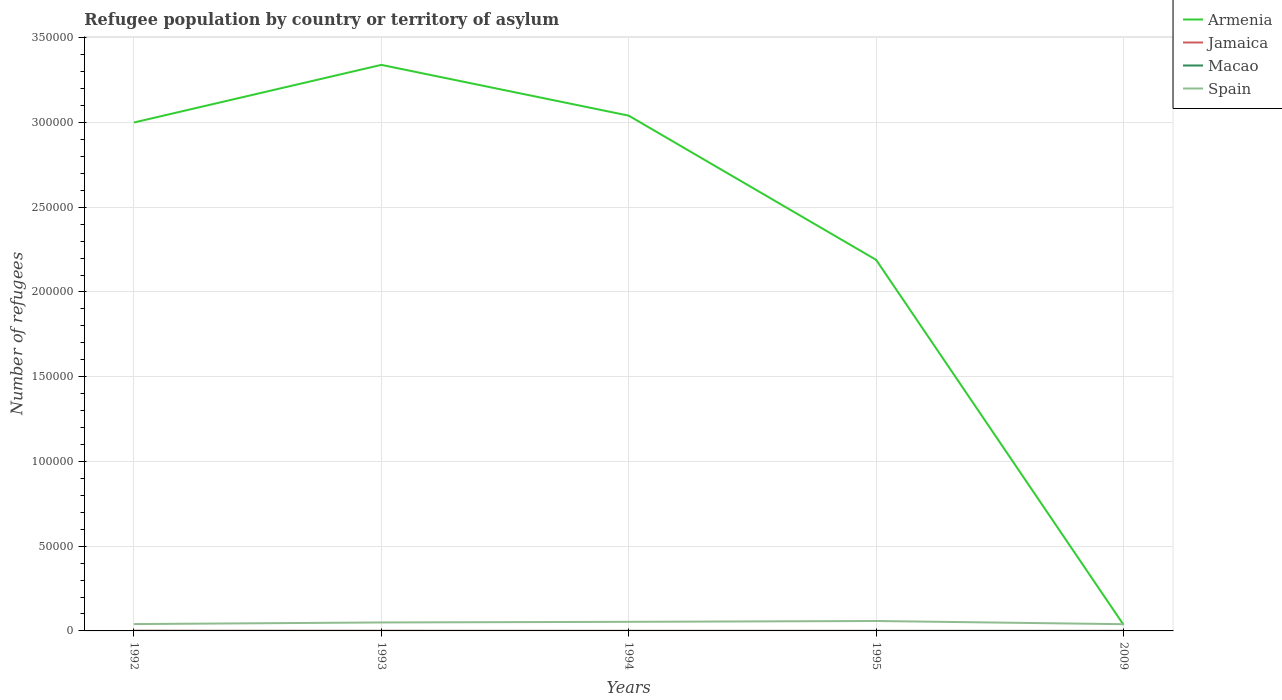Does the line corresponding to Armenia intersect with the line corresponding to Macao?
Keep it short and to the point. No. Is the number of lines equal to the number of legend labels?
Provide a succinct answer. Yes. Across all years, what is the maximum number of refugees in Spain?
Offer a very short reply. 3970. What is the total number of refugees in Armenia in the graph?
Provide a succinct answer. 1.15e+05. How many lines are there?
Ensure brevity in your answer.  4. How many years are there in the graph?
Ensure brevity in your answer.  5. Are the values on the major ticks of Y-axis written in scientific E-notation?
Ensure brevity in your answer.  No. Does the graph contain grids?
Your answer should be compact. Yes. Where does the legend appear in the graph?
Provide a succinct answer. Top right. How many legend labels are there?
Make the answer very short. 4. What is the title of the graph?
Provide a short and direct response. Refugee population by country or territory of asylum. Does "Lithuania" appear as one of the legend labels in the graph?
Give a very brief answer. No. What is the label or title of the X-axis?
Ensure brevity in your answer.  Years. What is the label or title of the Y-axis?
Make the answer very short. Number of refugees. What is the Number of refugees in Macao in 1992?
Keep it short and to the point. 15. What is the Number of refugees in Spain in 1992?
Offer a very short reply. 4036. What is the Number of refugees of Armenia in 1993?
Offer a very short reply. 3.34e+05. What is the Number of refugees in Spain in 1993?
Provide a succinct answer. 4997. What is the Number of refugees of Armenia in 1994?
Keep it short and to the point. 3.04e+05. What is the Number of refugees of Jamaica in 1994?
Offer a very short reply. 41. What is the Number of refugees in Macao in 1994?
Keep it short and to the point. 9. What is the Number of refugees in Spain in 1994?
Your answer should be compact. 5361. What is the Number of refugees in Armenia in 1995?
Keep it short and to the point. 2.19e+05. What is the Number of refugees of Spain in 1995?
Provide a succinct answer. 5852. What is the Number of refugees in Armenia in 2009?
Your answer should be very brief. 3607. What is the Number of refugees of Jamaica in 2009?
Give a very brief answer. 26. What is the Number of refugees of Macao in 2009?
Your answer should be very brief. 6. What is the Number of refugees of Spain in 2009?
Provide a succinct answer. 3970. Across all years, what is the maximum Number of refugees in Armenia?
Offer a terse response. 3.34e+05. Across all years, what is the maximum Number of refugees of Macao?
Your response must be concise. 15. Across all years, what is the maximum Number of refugees of Spain?
Offer a very short reply. 5852. Across all years, what is the minimum Number of refugees in Armenia?
Ensure brevity in your answer.  3607. Across all years, what is the minimum Number of refugees in Jamaica?
Your answer should be compact. 23. Across all years, what is the minimum Number of refugees in Spain?
Keep it short and to the point. 3970. What is the total Number of refugees in Armenia in the graph?
Offer a terse response. 1.16e+06. What is the total Number of refugees in Jamaica in the graph?
Your answer should be very brief. 243. What is the total Number of refugees of Spain in the graph?
Offer a terse response. 2.42e+04. What is the difference between the Number of refugees in Armenia in 1992 and that in 1993?
Offer a very short reply. -3.40e+04. What is the difference between the Number of refugees in Macao in 1992 and that in 1993?
Your answer should be very brief. 5. What is the difference between the Number of refugees in Spain in 1992 and that in 1993?
Provide a succinct answer. -961. What is the difference between the Number of refugees in Armenia in 1992 and that in 1994?
Offer a very short reply. -4039. What is the difference between the Number of refugees of Jamaica in 1992 and that in 1994?
Ensure brevity in your answer.  49. What is the difference between the Number of refugees in Macao in 1992 and that in 1994?
Provide a short and direct response. 6. What is the difference between the Number of refugees of Spain in 1992 and that in 1994?
Keep it short and to the point. -1325. What is the difference between the Number of refugees of Armenia in 1992 and that in 1995?
Offer a terse response. 8.10e+04. What is the difference between the Number of refugees of Jamaica in 1992 and that in 1995?
Provide a succinct answer. 67. What is the difference between the Number of refugees in Macao in 1992 and that in 1995?
Your response must be concise. 7. What is the difference between the Number of refugees in Spain in 1992 and that in 1995?
Provide a short and direct response. -1816. What is the difference between the Number of refugees of Armenia in 1992 and that in 2009?
Keep it short and to the point. 2.96e+05. What is the difference between the Number of refugees in Jamaica in 1992 and that in 2009?
Provide a succinct answer. 64. What is the difference between the Number of refugees of Spain in 1992 and that in 2009?
Your answer should be compact. 66. What is the difference between the Number of refugees of Armenia in 1993 and that in 1994?
Ensure brevity in your answer.  3.00e+04. What is the difference between the Number of refugees in Macao in 1993 and that in 1994?
Your response must be concise. 1. What is the difference between the Number of refugees of Spain in 1993 and that in 1994?
Your answer should be compact. -364. What is the difference between the Number of refugees of Armenia in 1993 and that in 1995?
Provide a short and direct response. 1.15e+05. What is the difference between the Number of refugees in Macao in 1993 and that in 1995?
Give a very brief answer. 2. What is the difference between the Number of refugees in Spain in 1993 and that in 1995?
Ensure brevity in your answer.  -855. What is the difference between the Number of refugees of Armenia in 1993 and that in 2009?
Make the answer very short. 3.30e+05. What is the difference between the Number of refugees in Macao in 1993 and that in 2009?
Make the answer very short. 4. What is the difference between the Number of refugees in Spain in 1993 and that in 2009?
Offer a very short reply. 1027. What is the difference between the Number of refugees in Armenia in 1994 and that in 1995?
Your answer should be compact. 8.51e+04. What is the difference between the Number of refugees of Jamaica in 1994 and that in 1995?
Your answer should be very brief. 18. What is the difference between the Number of refugees of Spain in 1994 and that in 1995?
Offer a very short reply. -491. What is the difference between the Number of refugees in Armenia in 1994 and that in 2009?
Offer a very short reply. 3.00e+05. What is the difference between the Number of refugees in Jamaica in 1994 and that in 2009?
Offer a terse response. 15. What is the difference between the Number of refugees in Macao in 1994 and that in 2009?
Make the answer very short. 3. What is the difference between the Number of refugees of Spain in 1994 and that in 2009?
Your response must be concise. 1391. What is the difference between the Number of refugees of Armenia in 1995 and that in 2009?
Your answer should be very brief. 2.15e+05. What is the difference between the Number of refugees of Jamaica in 1995 and that in 2009?
Your answer should be compact. -3. What is the difference between the Number of refugees in Macao in 1995 and that in 2009?
Your answer should be compact. 2. What is the difference between the Number of refugees of Spain in 1995 and that in 2009?
Offer a very short reply. 1882. What is the difference between the Number of refugees in Armenia in 1992 and the Number of refugees in Jamaica in 1993?
Offer a very short reply. 3.00e+05. What is the difference between the Number of refugees of Armenia in 1992 and the Number of refugees of Macao in 1993?
Your answer should be very brief. 3.00e+05. What is the difference between the Number of refugees in Armenia in 1992 and the Number of refugees in Spain in 1993?
Provide a succinct answer. 2.95e+05. What is the difference between the Number of refugees in Jamaica in 1992 and the Number of refugees in Spain in 1993?
Your answer should be compact. -4907. What is the difference between the Number of refugees in Macao in 1992 and the Number of refugees in Spain in 1993?
Provide a succinct answer. -4982. What is the difference between the Number of refugees of Armenia in 1992 and the Number of refugees of Jamaica in 1994?
Keep it short and to the point. 3.00e+05. What is the difference between the Number of refugees of Armenia in 1992 and the Number of refugees of Macao in 1994?
Provide a succinct answer. 3.00e+05. What is the difference between the Number of refugees in Armenia in 1992 and the Number of refugees in Spain in 1994?
Provide a succinct answer. 2.95e+05. What is the difference between the Number of refugees in Jamaica in 1992 and the Number of refugees in Macao in 1994?
Provide a short and direct response. 81. What is the difference between the Number of refugees in Jamaica in 1992 and the Number of refugees in Spain in 1994?
Offer a very short reply. -5271. What is the difference between the Number of refugees of Macao in 1992 and the Number of refugees of Spain in 1994?
Provide a short and direct response. -5346. What is the difference between the Number of refugees of Armenia in 1992 and the Number of refugees of Jamaica in 1995?
Provide a succinct answer. 3.00e+05. What is the difference between the Number of refugees of Armenia in 1992 and the Number of refugees of Macao in 1995?
Your response must be concise. 3.00e+05. What is the difference between the Number of refugees of Armenia in 1992 and the Number of refugees of Spain in 1995?
Give a very brief answer. 2.94e+05. What is the difference between the Number of refugees in Jamaica in 1992 and the Number of refugees in Spain in 1995?
Provide a succinct answer. -5762. What is the difference between the Number of refugees of Macao in 1992 and the Number of refugees of Spain in 1995?
Ensure brevity in your answer.  -5837. What is the difference between the Number of refugees of Armenia in 1992 and the Number of refugees of Jamaica in 2009?
Offer a very short reply. 3.00e+05. What is the difference between the Number of refugees of Armenia in 1992 and the Number of refugees of Macao in 2009?
Ensure brevity in your answer.  3.00e+05. What is the difference between the Number of refugees of Armenia in 1992 and the Number of refugees of Spain in 2009?
Give a very brief answer. 2.96e+05. What is the difference between the Number of refugees of Jamaica in 1992 and the Number of refugees of Spain in 2009?
Offer a very short reply. -3880. What is the difference between the Number of refugees of Macao in 1992 and the Number of refugees of Spain in 2009?
Offer a terse response. -3955. What is the difference between the Number of refugees in Armenia in 1993 and the Number of refugees in Jamaica in 1994?
Provide a succinct answer. 3.34e+05. What is the difference between the Number of refugees in Armenia in 1993 and the Number of refugees in Macao in 1994?
Ensure brevity in your answer.  3.34e+05. What is the difference between the Number of refugees of Armenia in 1993 and the Number of refugees of Spain in 1994?
Keep it short and to the point. 3.29e+05. What is the difference between the Number of refugees of Jamaica in 1993 and the Number of refugees of Spain in 1994?
Your answer should be compact. -5298. What is the difference between the Number of refugees of Macao in 1993 and the Number of refugees of Spain in 1994?
Give a very brief answer. -5351. What is the difference between the Number of refugees of Armenia in 1993 and the Number of refugees of Jamaica in 1995?
Offer a very short reply. 3.34e+05. What is the difference between the Number of refugees of Armenia in 1993 and the Number of refugees of Macao in 1995?
Provide a short and direct response. 3.34e+05. What is the difference between the Number of refugees in Armenia in 1993 and the Number of refugees in Spain in 1995?
Ensure brevity in your answer.  3.28e+05. What is the difference between the Number of refugees in Jamaica in 1993 and the Number of refugees in Macao in 1995?
Your response must be concise. 55. What is the difference between the Number of refugees in Jamaica in 1993 and the Number of refugees in Spain in 1995?
Ensure brevity in your answer.  -5789. What is the difference between the Number of refugees of Macao in 1993 and the Number of refugees of Spain in 1995?
Give a very brief answer. -5842. What is the difference between the Number of refugees in Armenia in 1993 and the Number of refugees in Jamaica in 2009?
Give a very brief answer. 3.34e+05. What is the difference between the Number of refugees in Armenia in 1993 and the Number of refugees in Macao in 2009?
Provide a succinct answer. 3.34e+05. What is the difference between the Number of refugees of Armenia in 1993 and the Number of refugees of Spain in 2009?
Make the answer very short. 3.30e+05. What is the difference between the Number of refugees of Jamaica in 1993 and the Number of refugees of Macao in 2009?
Provide a succinct answer. 57. What is the difference between the Number of refugees of Jamaica in 1993 and the Number of refugees of Spain in 2009?
Keep it short and to the point. -3907. What is the difference between the Number of refugees of Macao in 1993 and the Number of refugees of Spain in 2009?
Give a very brief answer. -3960. What is the difference between the Number of refugees of Armenia in 1994 and the Number of refugees of Jamaica in 1995?
Your response must be concise. 3.04e+05. What is the difference between the Number of refugees in Armenia in 1994 and the Number of refugees in Macao in 1995?
Ensure brevity in your answer.  3.04e+05. What is the difference between the Number of refugees of Armenia in 1994 and the Number of refugees of Spain in 1995?
Your answer should be very brief. 2.98e+05. What is the difference between the Number of refugees in Jamaica in 1994 and the Number of refugees in Macao in 1995?
Make the answer very short. 33. What is the difference between the Number of refugees in Jamaica in 1994 and the Number of refugees in Spain in 1995?
Offer a terse response. -5811. What is the difference between the Number of refugees of Macao in 1994 and the Number of refugees of Spain in 1995?
Offer a very short reply. -5843. What is the difference between the Number of refugees in Armenia in 1994 and the Number of refugees in Jamaica in 2009?
Provide a short and direct response. 3.04e+05. What is the difference between the Number of refugees in Armenia in 1994 and the Number of refugees in Macao in 2009?
Give a very brief answer. 3.04e+05. What is the difference between the Number of refugees of Armenia in 1994 and the Number of refugees of Spain in 2009?
Provide a succinct answer. 3.00e+05. What is the difference between the Number of refugees in Jamaica in 1994 and the Number of refugees in Spain in 2009?
Give a very brief answer. -3929. What is the difference between the Number of refugees of Macao in 1994 and the Number of refugees of Spain in 2009?
Give a very brief answer. -3961. What is the difference between the Number of refugees in Armenia in 1995 and the Number of refugees in Jamaica in 2009?
Offer a very short reply. 2.19e+05. What is the difference between the Number of refugees in Armenia in 1995 and the Number of refugees in Macao in 2009?
Your response must be concise. 2.19e+05. What is the difference between the Number of refugees of Armenia in 1995 and the Number of refugees of Spain in 2009?
Ensure brevity in your answer.  2.15e+05. What is the difference between the Number of refugees in Jamaica in 1995 and the Number of refugees in Spain in 2009?
Offer a very short reply. -3947. What is the difference between the Number of refugees in Macao in 1995 and the Number of refugees in Spain in 2009?
Your answer should be very brief. -3962. What is the average Number of refugees in Armenia per year?
Offer a terse response. 2.32e+05. What is the average Number of refugees in Jamaica per year?
Offer a terse response. 48.6. What is the average Number of refugees in Spain per year?
Offer a terse response. 4843.2. In the year 1992, what is the difference between the Number of refugees of Armenia and Number of refugees of Jamaica?
Make the answer very short. 3.00e+05. In the year 1992, what is the difference between the Number of refugees of Armenia and Number of refugees of Macao?
Give a very brief answer. 3.00e+05. In the year 1992, what is the difference between the Number of refugees in Armenia and Number of refugees in Spain?
Give a very brief answer. 2.96e+05. In the year 1992, what is the difference between the Number of refugees of Jamaica and Number of refugees of Spain?
Ensure brevity in your answer.  -3946. In the year 1992, what is the difference between the Number of refugees in Macao and Number of refugees in Spain?
Your answer should be compact. -4021. In the year 1993, what is the difference between the Number of refugees of Armenia and Number of refugees of Jamaica?
Offer a terse response. 3.34e+05. In the year 1993, what is the difference between the Number of refugees in Armenia and Number of refugees in Macao?
Keep it short and to the point. 3.34e+05. In the year 1993, what is the difference between the Number of refugees of Armenia and Number of refugees of Spain?
Provide a succinct answer. 3.29e+05. In the year 1993, what is the difference between the Number of refugees in Jamaica and Number of refugees in Macao?
Provide a succinct answer. 53. In the year 1993, what is the difference between the Number of refugees in Jamaica and Number of refugees in Spain?
Offer a terse response. -4934. In the year 1993, what is the difference between the Number of refugees in Macao and Number of refugees in Spain?
Your answer should be compact. -4987. In the year 1994, what is the difference between the Number of refugees in Armenia and Number of refugees in Jamaica?
Your answer should be very brief. 3.04e+05. In the year 1994, what is the difference between the Number of refugees in Armenia and Number of refugees in Macao?
Your answer should be very brief. 3.04e+05. In the year 1994, what is the difference between the Number of refugees of Armenia and Number of refugees of Spain?
Your answer should be very brief. 2.99e+05. In the year 1994, what is the difference between the Number of refugees of Jamaica and Number of refugees of Spain?
Your response must be concise. -5320. In the year 1994, what is the difference between the Number of refugees in Macao and Number of refugees in Spain?
Keep it short and to the point. -5352. In the year 1995, what is the difference between the Number of refugees in Armenia and Number of refugees in Jamaica?
Your response must be concise. 2.19e+05. In the year 1995, what is the difference between the Number of refugees of Armenia and Number of refugees of Macao?
Keep it short and to the point. 2.19e+05. In the year 1995, what is the difference between the Number of refugees in Armenia and Number of refugees in Spain?
Offer a very short reply. 2.13e+05. In the year 1995, what is the difference between the Number of refugees in Jamaica and Number of refugees in Macao?
Offer a terse response. 15. In the year 1995, what is the difference between the Number of refugees of Jamaica and Number of refugees of Spain?
Give a very brief answer. -5829. In the year 1995, what is the difference between the Number of refugees of Macao and Number of refugees of Spain?
Your response must be concise. -5844. In the year 2009, what is the difference between the Number of refugees of Armenia and Number of refugees of Jamaica?
Your response must be concise. 3581. In the year 2009, what is the difference between the Number of refugees of Armenia and Number of refugees of Macao?
Provide a succinct answer. 3601. In the year 2009, what is the difference between the Number of refugees of Armenia and Number of refugees of Spain?
Keep it short and to the point. -363. In the year 2009, what is the difference between the Number of refugees of Jamaica and Number of refugees of Macao?
Your response must be concise. 20. In the year 2009, what is the difference between the Number of refugees in Jamaica and Number of refugees in Spain?
Make the answer very short. -3944. In the year 2009, what is the difference between the Number of refugees in Macao and Number of refugees in Spain?
Give a very brief answer. -3964. What is the ratio of the Number of refugees in Armenia in 1992 to that in 1993?
Offer a very short reply. 0.9. What is the ratio of the Number of refugees in Jamaica in 1992 to that in 1993?
Ensure brevity in your answer.  1.43. What is the ratio of the Number of refugees of Macao in 1992 to that in 1993?
Offer a very short reply. 1.5. What is the ratio of the Number of refugees of Spain in 1992 to that in 1993?
Offer a very short reply. 0.81. What is the ratio of the Number of refugees of Armenia in 1992 to that in 1994?
Your response must be concise. 0.99. What is the ratio of the Number of refugees of Jamaica in 1992 to that in 1994?
Offer a terse response. 2.2. What is the ratio of the Number of refugees in Macao in 1992 to that in 1994?
Make the answer very short. 1.67. What is the ratio of the Number of refugees of Spain in 1992 to that in 1994?
Offer a very short reply. 0.75. What is the ratio of the Number of refugees of Armenia in 1992 to that in 1995?
Offer a very short reply. 1.37. What is the ratio of the Number of refugees in Jamaica in 1992 to that in 1995?
Ensure brevity in your answer.  3.91. What is the ratio of the Number of refugees in Macao in 1992 to that in 1995?
Give a very brief answer. 1.88. What is the ratio of the Number of refugees of Spain in 1992 to that in 1995?
Your answer should be compact. 0.69. What is the ratio of the Number of refugees of Armenia in 1992 to that in 2009?
Your response must be concise. 83.17. What is the ratio of the Number of refugees in Jamaica in 1992 to that in 2009?
Your answer should be very brief. 3.46. What is the ratio of the Number of refugees of Macao in 1992 to that in 2009?
Make the answer very short. 2.5. What is the ratio of the Number of refugees in Spain in 1992 to that in 2009?
Make the answer very short. 1.02. What is the ratio of the Number of refugees of Armenia in 1993 to that in 1994?
Your answer should be compact. 1.1. What is the ratio of the Number of refugees of Jamaica in 1993 to that in 1994?
Offer a terse response. 1.54. What is the ratio of the Number of refugees of Spain in 1993 to that in 1994?
Make the answer very short. 0.93. What is the ratio of the Number of refugees of Armenia in 1993 to that in 1995?
Offer a very short reply. 1.53. What is the ratio of the Number of refugees of Jamaica in 1993 to that in 1995?
Provide a short and direct response. 2.74. What is the ratio of the Number of refugees in Spain in 1993 to that in 1995?
Ensure brevity in your answer.  0.85. What is the ratio of the Number of refugees of Armenia in 1993 to that in 2009?
Make the answer very short. 92.6. What is the ratio of the Number of refugees of Jamaica in 1993 to that in 2009?
Your answer should be compact. 2.42. What is the ratio of the Number of refugees of Macao in 1993 to that in 2009?
Keep it short and to the point. 1.67. What is the ratio of the Number of refugees of Spain in 1993 to that in 2009?
Your answer should be compact. 1.26. What is the ratio of the Number of refugees in Armenia in 1994 to that in 1995?
Keep it short and to the point. 1.39. What is the ratio of the Number of refugees in Jamaica in 1994 to that in 1995?
Offer a very short reply. 1.78. What is the ratio of the Number of refugees of Macao in 1994 to that in 1995?
Your answer should be very brief. 1.12. What is the ratio of the Number of refugees of Spain in 1994 to that in 1995?
Your answer should be compact. 0.92. What is the ratio of the Number of refugees in Armenia in 1994 to that in 2009?
Your answer should be very brief. 84.29. What is the ratio of the Number of refugees in Jamaica in 1994 to that in 2009?
Keep it short and to the point. 1.58. What is the ratio of the Number of refugees in Spain in 1994 to that in 2009?
Your answer should be compact. 1.35. What is the ratio of the Number of refugees in Armenia in 1995 to that in 2009?
Make the answer very short. 60.7. What is the ratio of the Number of refugees of Jamaica in 1995 to that in 2009?
Give a very brief answer. 0.88. What is the ratio of the Number of refugees in Spain in 1995 to that in 2009?
Keep it short and to the point. 1.47. What is the difference between the highest and the second highest Number of refugees in Armenia?
Your answer should be compact. 3.00e+04. What is the difference between the highest and the second highest Number of refugees of Spain?
Your answer should be compact. 491. What is the difference between the highest and the lowest Number of refugees in Armenia?
Provide a short and direct response. 3.30e+05. What is the difference between the highest and the lowest Number of refugees in Macao?
Your answer should be compact. 9. What is the difference between the highest and the lowest Number of refugees in Spain?
Ensure brevity in your answer.  1882. 